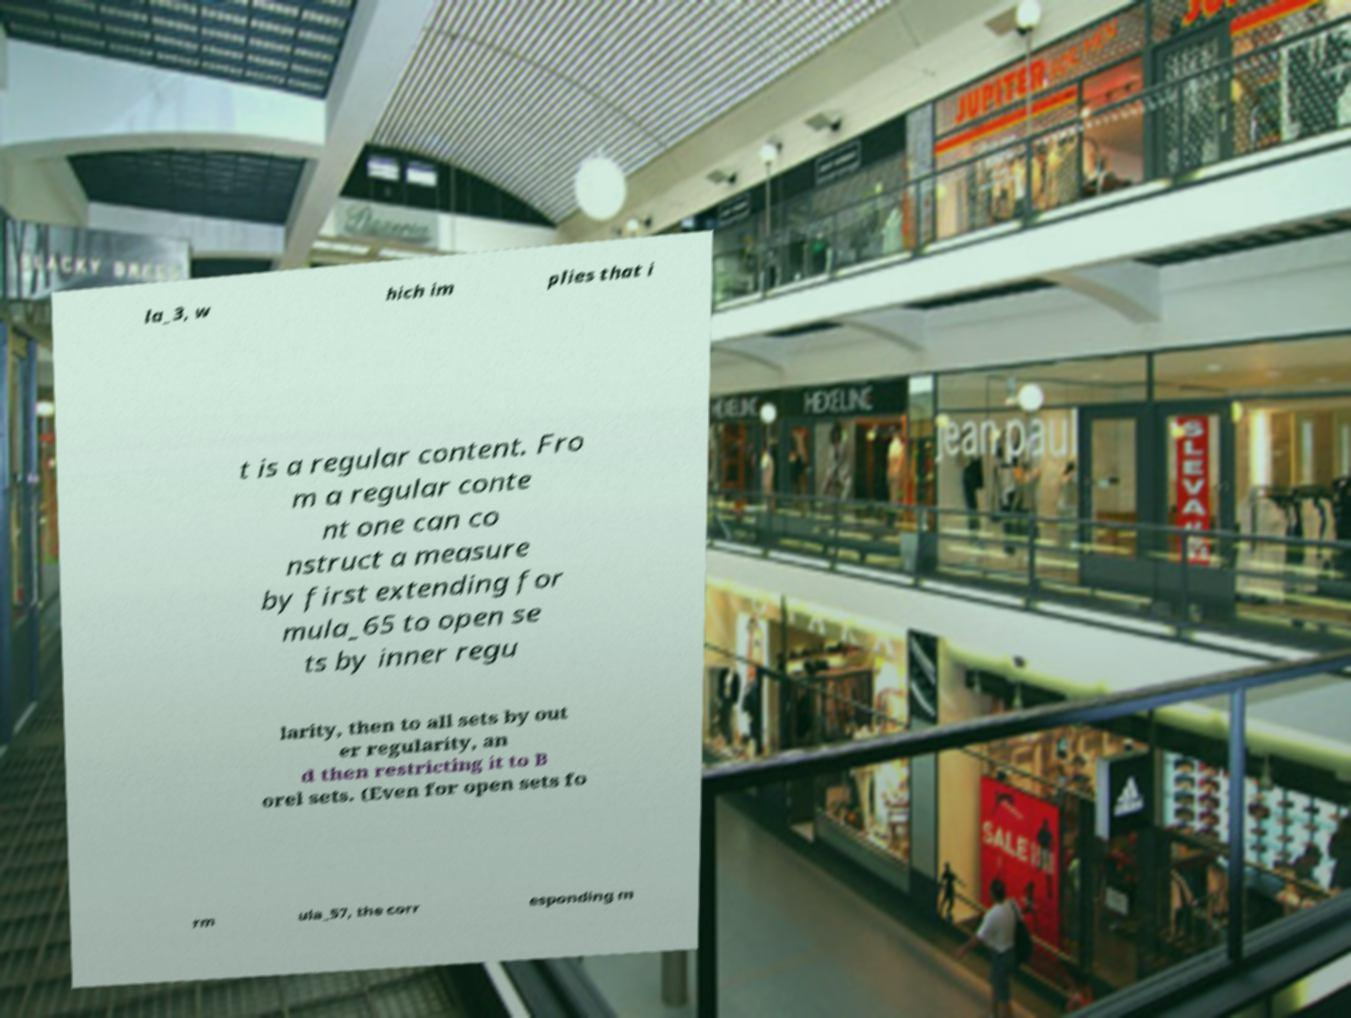For documentation purposes, I need the text within this image transcribed. Could you provide that? la_3, w hich im plies that i t is a regular content. Fro m a regular conte nt one can co nstruct a measure by first extending for mula_65 to open se ts by inner regu larity, then to all sets by out er regularity, an d then restricting it to B orel sets. (Even for open sets fo rm ula_57, the corr esponding m 